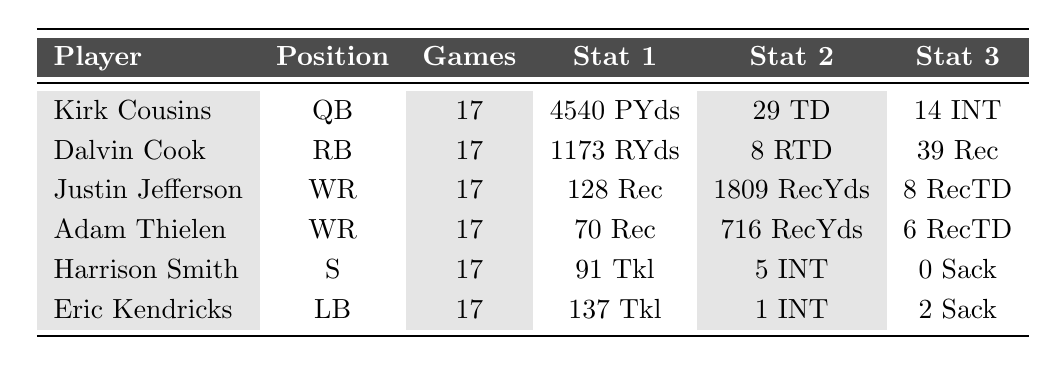What position does Kirk Cousins play? The table shows that Kirk Cousins is in the row under the "Player" column, which identifies him as the Quarterback (QB).
Answer: Quarterback How many total rushing touchdowns did Dalvin Cook score? The table provides a column for "Rush Touchdowns" for Dalvin Cook, and it lists the value as 8.
Answer: 8 Which player had the most receiving yards? By checking the "Receiving Yards" column, Justin Jefferson has the highest value at 1809 yards compared to the other players.
Answer: Justin Jefferson Did Harrison Smith record any sacks last season? The "Sacks" column for Harrison Smith shows a value of 0, indicating he did not record any.
Answer: No What is the average number of games played by the players listed? Each player played 17 games, so adding 17 for each of the 6 players gives 102, then dividing by 6 gives an average of 17.
Answer: 17 Who had the highest number of tackles? Eric Kendricks has the highest value in the "Tackles" column with 137 tackles, which is more than Harrison Smith's 91 tackles.
Answer: Eric Kendricks Is it true that all players played the same number of games? The "Games Played" column shows that each player is listed with 17 games, confirming that they all played the same number of games.
Answer: Yes What is the total number of interceptions thrown by Kirk Cousins and recorded by Eric Kendricks? Kirk Cousins threw 14 interceptions, and Eric Kendricks had 1 interception. Adding these together gives 14 + 1 = 15.
Answer: 15 Which player scored the most touchdowns overall (pass, rush, or receiving)? First, we look at Kirk Cousins for passing touchdowns (29), Dalvin Cook for rushing touchdowns (8), and Justin Jefferson/Adam Thielen for receiving touchdowns (8 and 6, respectively). The highest is 29 by Kirk Cousins.
Answer: Kirk Cousins What percentage of the total tackles do Eric Kendricks' tackles represent? Eric Kendricks has 137 tackles, and to find the total, we add up all tackles for Harrison Smith (91) and Eric Kendricks (137), giving 228 total tackles. Now calculate (137/228) * 100 which equals approximately 60.09%.
Answer: 60.09% 